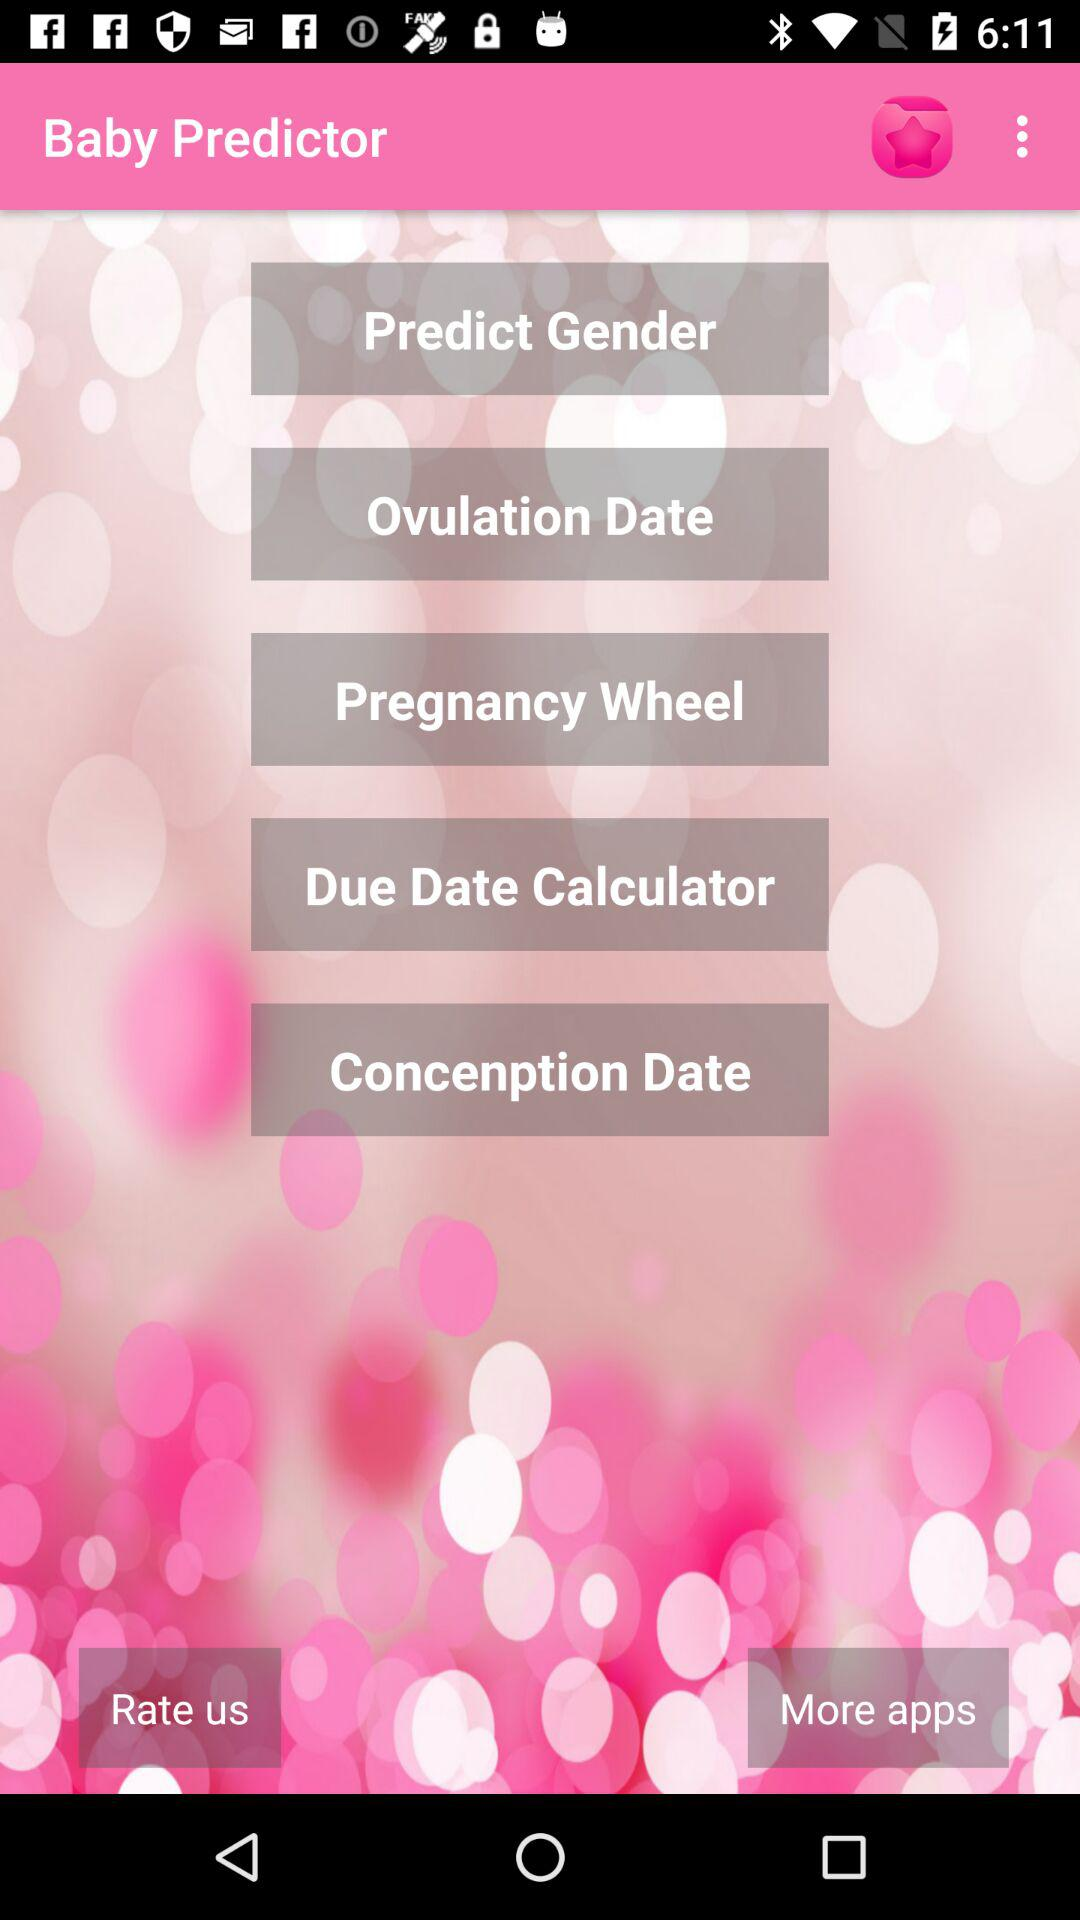What is the name of the application? The name of the application is "Baby Predictor". 